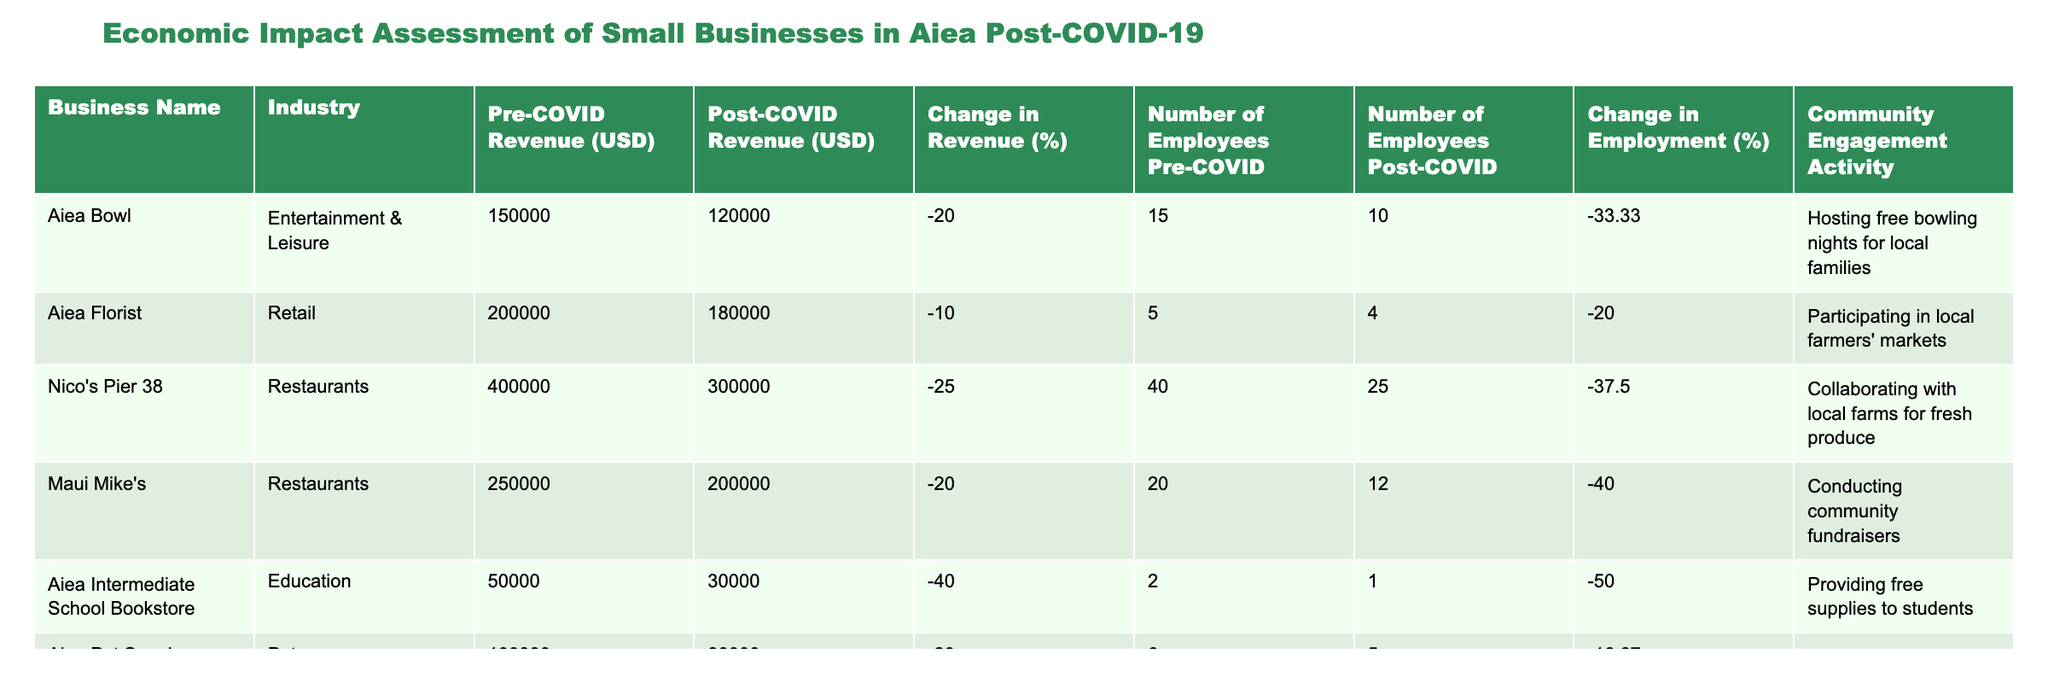What is the revenue change for Aiea Bowl post-COVID-19? The table indicates that the pre-COVID revenue for Aiea Bowl was 150,000 USD and the post-COVID revenue is 120,000 USD. The change in revenue can be calculated as (120,000 - 150,000) / 150,000 * 100 = -20%.
Answer: -20% Which business experienced the most significant change in employment after COVID-19? Looking at the "Change in Employment (%)" column, Aiea Intermediate School Bookstore shows a change of -50%, which is the highest reduction in employment among the listed businesses.
Answer: Aiea Intermediate School Bookstore What is the average change in revenue among all businesses listed? The changes in revenue percentages are -20, -10, -25, -20, -40, and -20. The average change is calculated as (-20 -10 -25 -20 -40 -20) / 6 = -20.83%.
Answer: -20.83% Did Aiea Florist increase or decrease its employment after COVID-19? The table shows that Aiea Florist had 5 employees pre-COVID and 4 employees post-COVID, indicating a reduction in employment.
Answer: Decrease Are there any businesses that had a revenue change of more than -30%? By checking the "Change in Revenue (%)" column, Nico's Pier 38 (-25%) and Maui Mike's (-20%) both had changes less than -30%. Thus, there are no businesses with a revenue change greater than -30%.
Answer: No Which industry saw the largest revenue drop in Aiea post-COVID-19? By examining the "Change in Revenue (%)" figures, the Education industry (Aiea Intermediate School Bookstore with -40%) experienced the largest drop in revenue compared to others listed.
Answer: Education How many businesses have reported losses in both revenue and employment? In the table, both Aiea Intermediate School Bookstore and Maui Mike's reported losses in revenue (-40%, -20%) and in employment (-50%, -40%), respectively, accounting for two businesses.
Answer: Two businesses What total number of employees were lost across all businesses? We can calculate the total employee loss by subtracting pre-COVID employment from post-COVID employment for each business: (15-10) + (5-4) + (40-25) + (20-12) + (2-1) + (6-5) = 5 + 1 + 15 + 8 + 1 + 1 = 31. Therefore, the total number of employees lost across all businesses is 31.
Answer: 31 